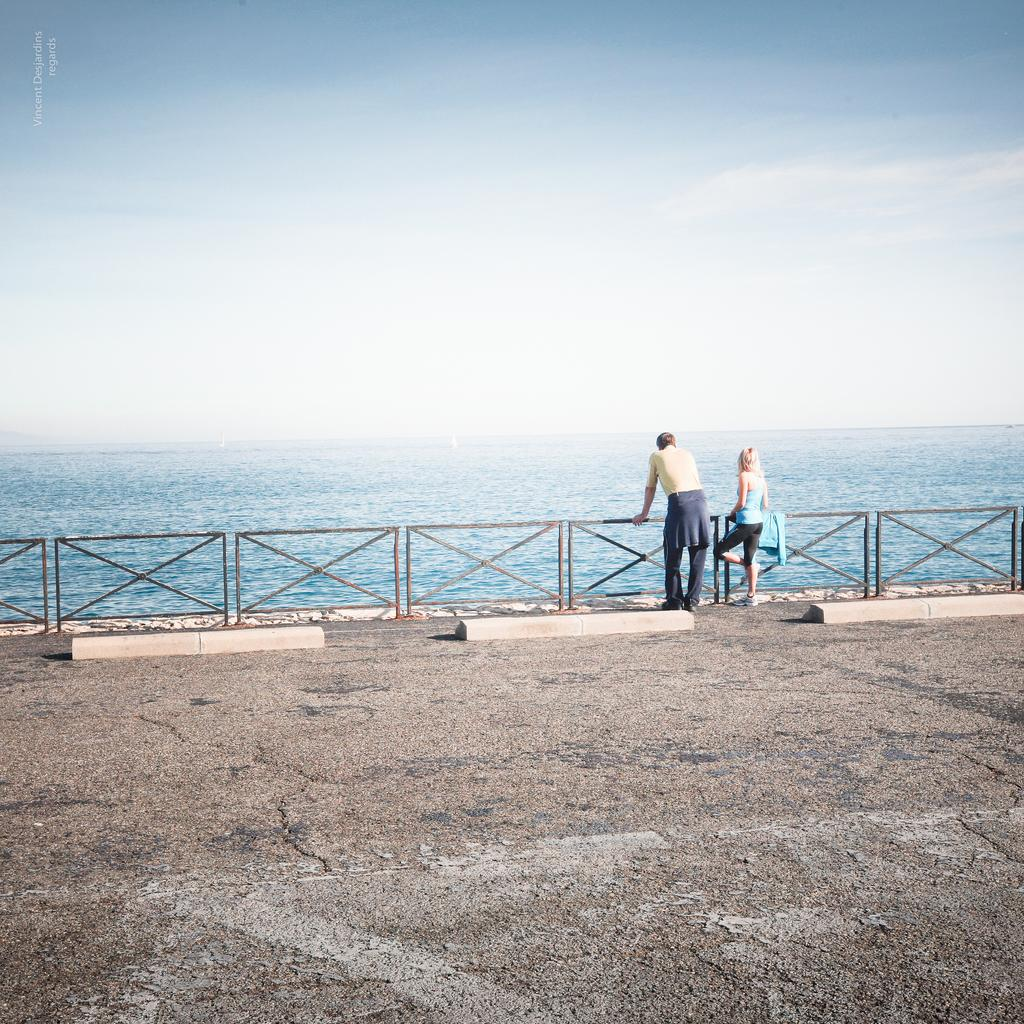How many people are in the image? There are two persons in the image. What are the persons doing in the image? The persons are standing near a railing. What can be seen in the background of the image? Water and the sky are visible in the background of the image. What type of banana is being used as a vase in the image? There is no banana or vase present in the image. 